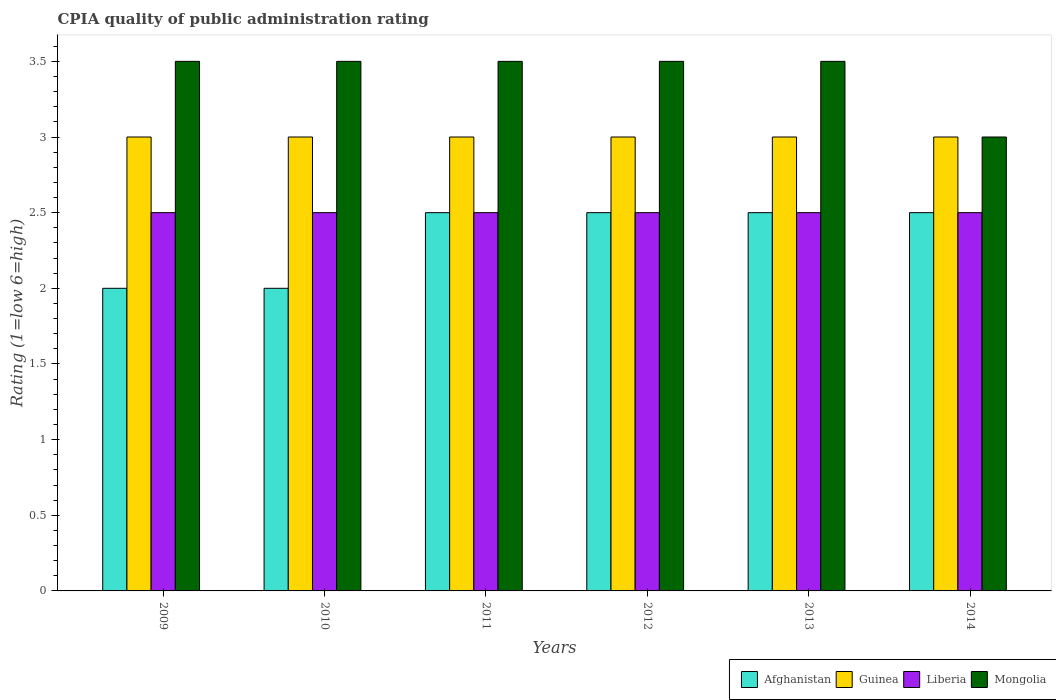How many different coloured bars are there?
Ensure brevity in your answer.  4. How many groups of bars are there?
Ensure brevity in your answer.  6. Are the number of bars on each tick of the X-axis equal?
Keep it short and to the point. Yes. How many bars are there on the 5th tick from the left?
Your answer should be compact. 4. How many bars are there on the 4th tick from the right?
Your answer should be compact. 4. What is the label of the 6th group of bars from the left?
Provide a short and direct response. 2014. What is the CPIA rating in Liberia in 2012?
Offer a terse response. 2.5. What is the total CPIA rating in Liberia in the graph?
Make the answer very short. 15. What is the difference between the CPIA rating in Afghanistan in 2009 and that in 2014?
Your response must be concise. -0.5. What is the difference between the CPIA rating in Guinea in 2011 and the CPIA rating in Liberia in 2013?
Keep it short and to the point. 0.5. What is the average CPIA rating in Mongolia per year?
Offer a terse response. 3.42. What is the ratio of the CPIA rating in Afghanistan in 2010 to that in 2012?
Offer a terse response. 0.8. What is the difference between the highest and the lowest CPIA rating in Liberia?
Make the answer very short. 0. Is it the case that in every year, the sum of the CPIA rating in Liberia and CPIA rating in Mongolia is greater than the sum of CPIA rating in Guinea and CPIA rating in Afghanistan?
Your answer should be very brief. No. What does the 3rd bar from the left in 2012 represents?
Your response must be concise. Liberia. What does the 3rd bar from the right in 2009 represents?
Provide a succinct answer. Guinea. How many bars are there?
Your response must be concise. 24. Does the graph contain grids?
Offer a very short reply. No. How many legend labels are there?
Your response must be concise. 4. What is the title of the graph?
Offer a terse response. CPIA quality of public administration rating. Does "New Zealand" appear as one of the legend labels in the graph?
Provide a short and direct response. No. What is the label or title of the Y-axis?
Offer a very short reply. Rating (1=low 6=high). What is the Rating (1=low 6=high) in Afghanistan in 2009?
Your answer should be compact. 2. What is the Rating (1=low 6=high) in Mongolia in 2009?
Offer a very short reply. 3.5. What is the Rating (1=low 6=high) in Afghanistan in 2010?
Your answer should be very brief. 2. What is the Rating (1=low 6=high) of Guinea in 2010?
Ensure brevity in your answer.  3. What is the Rating (1=low 6=high) in Guinea in 2011?
Offer a very short reply. 3. What is the Rating (1=low 6=high) of Liberia in 2011?
Give a very brief answer. 2.5. What is the Rating (1=low 6=high) in Afghanistan in 2012?
Your answer should be compact. 2.5. What is the Rating (1=low 6=high) of Guinea in 2012?
Provide a succinct answer. 3. What is the Rating (1=low 6=high) in Liberia in 2012?
Offer a very short reply. 2.5. What is the Rating (1=low 6=high) in Mongolia in 2012?
Give a very brief answer. 3.5. What is the Rating (1=low 6=high) of Afghanistan in 2013?
Make the answer very short. 2.5. What is the Rating (1=low 6=high) in Guinea in 2013?
Your response must be concise. 3. What is the Rating (1=low 6=high) of Liberia in 2013?
Ensure brevity in your answer.  2.5. What is the Rating (1=low 6=high) of Liberia in 2014?
Your response must be concise. 2.5. What is the Rating (1=low 6=high) in Mongolia in 2014?
Your answer should be very brief. 3. Across all years, what is the maximum Rating (1=low 6=high) in Afghanistan?
Make the answer very short. 2.5. Across all years, what is the maximum Rating (1=low 6=high) in Liberia?
Offer a terse response. 2.5. Across all years, what is the minimum Rating (1=low 6=high) in Mongolia?
Keep it short and to the point. 3. What is the total Rating (1=low 6=high) of Mongolia in the graph?
Provide a short and direct response. 20.5. What is the difference between the Rating (1=low 6=high) in Liberia in 2009 and that in 2010?
Offer a terse response. 0. What is the difference between the Rating (1=low 6=high) of Liberia in 2009 and that in 2011?
Your answer should be compact. 0. What is the difference between the Rating (1=low 6=high) of Mongolia in 2009 and that in 2011?
Give a very brief answer. 0. What is the difference between the Rating (1=low 6=high) in Guinea in 2009 and that in 2013?
Provide a short and direct response. 0. What is the difference between the Rating (1=low 6=high) in Mongolia in 2009 and that in 2013?
Provide a short and direct response. 0. What is the difference between the Rating (1=low 6=high) in Afghanistan in 2009 and that in 2014?
Your answer should be very brief. -0.5. What is the difference between the Rating (1=low 6=high) in Mongolia in 2009 and that in 2014?
Your response must be concise. 0.5. What is the difference between the Rating (1=low 6=high) in Liberia in 2010 and that in 2011?
Make the answer very short. 0. What is the difference between the Rating (1=low 6=high) in Guinea in 2010 and that in 2012?
Provide a short and direct response. 0. What is the difference between the Rating (1=low 6=high) of Liberia in 2010 and that in 2012?
Make the answer very short. 0. What is the difference between the Rating (1=low 6=high) of Mongolia in 2010 and that in 2013?
Provide a short and direct response. 0. What is the difference between the Rating (1=low 6=high) of Liberia in 2010 and that in 2014?
Keep it short and to the point. 0. What is the difference between the Rating (1=low 6=high) of Mongolia in 2010 and that in 2014?
Give a very brief answer. 0.5. What is the difference between the Rating (1=low 6=high) in Liberia in 2011 and that in 2012?
Ensure brevity in your answer.  0. What is the difference between the Rating (1=low 6=high) of Mongolia in 2011 and that in 2012?
Give a very brief answer. 0. What is the difference between the Rating (1=low 6=high) of Afghanistan in 2011 and that in 2013?
Provide a short and direct response. 0. What is the difference between the Rating (1=low 6=high) of Mongolia in 2011 and that in 2013?
Your answer should be very brief. 0. What is the difference between the Rating (1=low 6=high) of Afghanistan in 2011 and that in 2014?
Provide a succinct answer. 0. What is the difference between the Rating (1=low 6=high) in Guinea in 2011 and that in 2014?
Provide a succinct answer. 0. What is the difference between the Rating (1=low 6=high) in Mongolia in 2011 and that in 2014?
Your answer should be compact. 0.5. What is the difference between the Rating (1=low 6=high) of Afghanistan in 2012 and that in 2013?
Your answer should be very brief. 0. What is the difference between the Rating (1=low 6=high) in Guinea in 2012 and that in 2013?
Provide a short and direct response. 0. What is the difference between the Rating (1=low 6=high) in Liberia in 2012 and that in 2013?
Provide a short and direct response. 0. What is the difference between the Rating (1=low 6=high) in Mongolia in 2012 and that in 2013?
Make the answer very short. 0. What is the difference between the Rating (1=low 6=high) in Afghanistan in 2012 and that in 2014?
Your answer should be very brief. 0. What is the difference between the Rating (1=low 6=high) in Guinea in 2012 and that in 2014?
Ensure brevity in your answer.  0. What is the difference between the Rating (1=low 6=high) of Liberia in 2012 and that in 2014?
Ensure brevity in your answer.  0. What is the difference between the Rating (1=low 6=high) of Mongolia in 2012 and that in 2014?
Your answer should be compact. 0.5. What is the difference between the Rating (1=low 6=high) of Afghanistan in 2013 and that in 2014?
Provide a succinct answer. 0. What is the difference between the Rating (1=low 6=high) in Guinea in 2013 and that in 2014?
Your answer should be compact. 0. What is the difference between the Rating (1=low 6=high) of Mongolia in 2013 and that in 2014?
Keep it short and to the point. 0.5. What is the difference between the Rating (1=low 6=high) of Afghanistan in 2009 and the Rating (1=low 6=high) of Guinea in 2010?
Your answer should be compact. -1. What is the difference between the Rating (1=low 6=high) of Afghanistan in 2009 and the Rating (1=low 6=high) of Liberia in 2010?
Make the answer very short. -0.5. What is the difference between the Rating (1=low 6=high) in Afghanistan in 2009 and the Rating (1=low 6=high) in Mongolia in 2010?
Provide a short and direct response. -1.5. What is the difference between the Rating (1=low 6=high) in Liberia in 2009 and the Rating (1=low 6=high) in Mongolia in 2010?
Offer a terse response. -1. What is the difference between the Rating (1=low 6=high) of Afghanistan in 2009 and the Rating (1=low 6=high) of Guinea in 2011?
Keep it short and to the point. -1. What is the difference between the Rating (1=low 6=high) in Afghanistan in 2009 and the Rating (1=low 6=high) in Liberia in 2011?
Your response must be concise. -0.5. What is the difference between the Rating (1=low 6=high) of Guinea in 2009 and the Rating (1=low 6=high) of Liberia in 2011?
Your answer should be compact. 0.5. What is the difference between the Rating (1=low 6=high) in Guinea in 2009 and the Rating (1=low 6=high) in Mongolia in 2011?
Offer a very short reply. -0.5. What is the difference between the Rating (1=low 6=high) of Afghanistan in 2009 and the Rating (1=low 6=high) of Liberia in 2012?
Provide a succinct answer. -0.5. What is the difference between the Rating (1=low 6=high) in Afghanistan in 2009 and the Rating (1=low 6=high) in Mongolia in 2012?
Keep it short and to the point. -1.5. What is the difference between the Rating (1=low 6=high) of Guinea in 2009 and the Rating (1=low 6=high) of Liberia in 2012?
Make the answer very short. 0.5. What is the difference between the Rating (1=low 6=high) of Guinea in 2009 and the Rating (1=low 6=high) of Mongolia in 2012?
Offer a terse response. -0.5. What is the difference between the Rating (1=low 6=high) in Liberia in 2009 and the Rating (1=low 6=high) in Mongolia in 2012?
Your answer should be compact. -1. What is the difference between the Rating (1=low 6=high) in Afghanistan in 2009 and the Rating (1=low 6=high) in Guinea in 2013?
Provide a succinct answer. -1. What is the difference between the Rating (1=low 6=high) of Afghanistan in 2009 and the Rating (1=low 6=high) of Mongolia in 2013?
Give a very brief answer. -1.5. What is the difference between the Rating (1=low 6=high) of Guinea in 2009 and the Rating (1=low 6=high) of Liberia in 2013?
Offer a very short reply. 0.5. What is the difference between the Rating (1=low 6=high) of Guinea in 2009 and the Rating (1=low 6=high) of Mongolia in 2013?
Your response must be concise. -0.5. What is the difference between the Rating (1=low 6=high) of Afghanistan in 2009 and the Rating (1=low 6=high) of Guinea in 2014?
Keep it short and to the point. -1. What is the difference between the Rating (1=low 6=high) in Afghanistan in 2009 and the Rating (1=low 6=high) in Mongolia in 2014?
Give a very brief answer. -1. What is the difference between the Rating (1=low 6=high) of Guinea in 2010 and the Rating (1=low 6=high) of Mongolia in 2011?
Offer a terse response. -0.5. What is the difference between the Rating (1=low 6=high) of Afghanistan in 2010 and the Rating (1=low 6=high) of Liberia in 2012?
Offer a terse response. -0.5. What is the difference between the Rating (1=low 6=high) in Guinea in 2010 and the Rating (1=low 6=high) in Liberia in 2012?
Provide a short and direct response. 0.5. What is the difference between the Rating (1=low 6=high) of Liberia in 2010 and the Rating (1=low 6=high) of Mongolia in 2012?
Make the answer very short. -1. What is the difference between the Rating (1=low 6=high) of Afghanistan in 2010 and the Rating (1=low 6=high) of Guinea in 2013?
Ensure brevity in your answer.  -1. What is the difference between the Rating (1=low 6=high) in Afghanistan in 2010 and the Rating (1=low 6=high) in Liberia in 2013?
Offer a terse response. -0.5. What is the difference between the Rating (1=low 6=high) of Guinea in 2010 and the Rating (1=low 6=high) of Liberia in 2013?
Keep it short and to the point. 0.5. What is the difference between the Rating (1=low 6=high) of Guinea in 2010 and the Rating (1=low 6=high) of Mongolia in 2013?
Offer a terse response. -0.5. What is the difference between the Rating (1=low 6=high) of Liberia in 2010 and the Rating (1=low 6=high) of Mongolia in 2013?
Offer a very short reply. -1. What is the difference between the Rating (1=low 6=high) of Afghanistan in 2010 and the Rating (1=low 6=high) of Liberia in 2014?
Offer a terse response. -0.5. What is the difference between the Rating (1=low 6=high) of Guinea in 2010 and the Rating (1=low 6=high) of Liberia in 2014?
Offer a very short reply. 0.5. What is the difference between the Rating (1=low 6=high) in Guinea in 2010 and the Rating (1=low 6=high) in Mongolia in 2014?
Provide a succinct answer. 0. What is the difference between the Rating (1=low 6=high) of Afghanistan in 2011 and the Rating (1=low 6=high) of Mongolia in 2012?
Your answer should be compact. -1. What is the difference between the Rating (1=low 6=high) of Guinea in 2011 and the Rating (1=low 6=high) of Mongolia in 2012?
Give a very brief answer. -0.5. What is the difference between the Rating (1=low 6=high) of Liberia in 2011 and the Rating (1=low 6=high) of Mongolia in 2012?
Provide a succinct answer. -1. What is the difference between the Rating (1=low 6=high) in Afghanistan in 2011 and the Rating (1=low 6=high) in Guinea in 2013?
Give a very brief answer. -0.5. What is the difference between the Rating (1=low 6=high) in Guinea in 2011 and the Rating (1=low 6=high) in Mongolia in 2013?
Make the answer very short. -0.5. What is the difference between the Rating (1=low 6=high) in Liberia in 2011 and the Rating (1=low 6=high) in Mongolia in 2014?
Your answer should be very brief. -0.5. What is the difference between the Rating (1=low 6=high) in Afghanistan in 2012 and the Rating (1=low 6=high) in Liberia in 2013?
Provide a short and direct response. 0. What is the difference between the Rating (1=low 6=high) of Afghanistan in 2012 and the Rating (1=low 6=high) of Mongolia in 2013?
Make the answer very short. -1. What is the difference between the Rating (1=low 6=high) of Guinea in 2012 and the Rating (1=low 6=high) of Liberia in 2013?
Offer a very short reply. 0.5. What is the difference between the Rating (1=low 6=high) in Guinea in 2012 and the Rating (1=low 6=high) in Mongolia in 2013?
Offer a very short reply. -0.5. What is the difference between the Rating (1=low 6=high) of Liberia in 2012 and the Rating (1=low 6=high) of Mongolia in 2013?
Provide a short and direct response. -1. What is the difference between the Rating (1=low 6=high) in Afghanistan in 2012 and the Rating (1=low 6=high) in Guinea in 2014?
Offer a terse response. -0.5. What is the difference between the Rating (1=low 6=high) in Liberia in 2012 and the Rating (1=low 6=high) in Mongolia in 2014?
Your answer should be compact. -0.5. What is the difference between the Rating (1=low 6=high) in Afghanistan in 2013 and the Rating (1=low 6=high) in Guinea in 2014?
Your answer should be compact. -0.5. What is the difference between the Rating (1=low 6=high) in Afghanistan in 2013 and the Rating (1=low 6=high) in Mongolia in 2014?
Offer a very short reply. -0.5. What is the difference between the Rating (1=low 6=high) of Guinea in 2013 and the Rating (1=low 6=high) of Liberia in 2014?
Your answer should be very brief. 0.5. What is the difference between the Rating (1=low 6=high) in Guinea in 2013 and the Rating (1=low 6=high) in Mongolia in 2014?
Provide a succinct answer. 0. What is the average Rating (1=low 6=high) in Afghanistan per year?
Make the answer very short. 2.33. What is the average Rating (1=low 6=high) of Mongolia per year?
Make the answer very short. 3.42. In the year 2010, what is the difference between the Rating (1=low 6=high) of Afghanistan and Rating (1=low 6=high) of Guinea?
Keep it short and to the point. -1. In the year 2010, what is the difference between the Rating (1=low 6=high) in Afghanistan and Rating (1=low 6=high) in Mongolia?
Your answer should be compact. -1.5. In the year 2011, what is the difference between the Rating (1=low 6=high) in Afghanistan and Rating (1=low 6=high) in Liberia?
Offer a very short reply. 0. In the year 2011, what is the difference between the Rating (1=low 6=high) of Afghanistan and Rating (1=low 6=high) of Mongolia?
Give a very brief answer. -1. In the year 2011, what is the difference between the Rating (1=low 6=high) of Guinea and Rating (1=low 6=high) of Liberia?
Keep it short and to the point. 0.5. In the year 2011, what is the difference between the Rating (1=low 6=high) in Guinea and Rating (1=low 6=high) in Mongolia?
Ensure brevity in your answer.  -0.5. In the year 2011, what is the difference between the Rating (1=low 6=high) in Liberia and Rating (1=low 6=high) in Mongolia?
Keep it short and to the point. -1. In the year 2012, what is the difference between the Rating (1=low 6=high) in Afghanistan and Rating (1=low 6=high) in Liberia?
Ensure brevity in your answer.  0. In the year 2012, what is the difference between the Rating (1=low 6=high) in Afghanistan and Rating (1=low 6=high) in Mongolia?
Your response must be concise. -1. In the year 2012, what is the difference between the Rating (1=low 6=high) of Guinea and Rating (1=low 6=high) of Mongolia?
Keep it short and to the point. -0.5. In the year 2013, what is the difference between the Rating (1=low 6=high) in Afghanistan and Rating (1=low 6=high) in Mongolia?
Your answer should be compact. -1. In the year 2014, what is the difference between the Rating (1=low 6=high) of Afghanistan and Rating (1=low 6=high) of Mongolia?
Give a very brief answer. -0.5. In the year 2014, what is the difference between the Rating (1=low 6=high) of Guinea and Rating (1=low 6=high) of Mongolia?
Your answer should be compact. 0. In the year 2014, what is the difference between the Rating (1=low 6=high) of Liberia and Rating (1=low 6=high) of Mongolia?
Offer a very short reply. -0.5. What is the ratio of the Rating (1=low 6=high) of Guinea in 2009 to that in 2010?
Your answer should be very brief. 1. What is the ratio of the Rating (1=low 6=high) of Liberia in 2009 to that in 2010?
Provide a short and direct response. 1. What is the ratio of the Rating (1=low 6=high) of Mongolia in 2009 to that in 2010?
Give a very brief answer. 1. What is the ratio of the Rating (1=low 6=high) in Afghanistan in 2009 to that in 2011?
Your answer should be compact. 0.8. What is the ratio of the Rating (1=low 6=high) in Guinea in 2009 to that in 2012?
Your answer should be very brief. 1. What is the ratio of the Rating (1=low 6=high) of Mongolia in 2009 to that in 2012?
Offer a terse response. 1. What is the ratio of the Rating (1=low 6=high) in Afghanistan in 2009 to that in 2014?
Make the answer very short. 0.8. What is the ratio of the Rating (1=low 6=high) of Guinea in 2009 to that in 2014?
Your response must be concise. 1. What is the ratio of the Rating (1=low 6=high) of Mongolia in 2009 to that in 2014?
Ensure brevity in your answer.  1.17. What is the ratio of the Rating (1=low 6=high) of Guinea in 2010 to that in 2011?
Your answer should be very brief. 1. What is the ratio of the Rating (1=low 6=high) in Mongolia in 2010 to that in 2011?
Provide a short and direct response. 1. What is the ratio of the Rating (1=low 6=high) of Guinea in 2010 to that in 2013?
Your answer should be very brief. 1. What is the ratio of the Rating (1=low 6=high) of Liberia in 2010 to that in 2014?
Provide a succinct answer. 1. What is the ratio of the Rating (1=low 6=high) in Afghanistan in 2011 to that in 2012?
Provide a succinct answer. 1. What is the ratio of the Rating (1=low 6=high) of Guinea in 2011 to that in 2012?
Offer a terse response. 1. What is the ratio of the Rating (1=low 6=high) in Mongolia in 2011 to that in 2013?
Keep it short and to the point. 1. What is the ratio of the Rating (1=low 6=high) of Liberia in 2011 to that in 2014?
Your answer should be compact. 1. What is the ratio of the Rating (1=low 6=high) in Afghanistan in 2012 to that in 2013?
Provide a short and direct response. 1. What is the ratio of the Rating (1=low 6=high) in Afghanistan in 2012 to that in 2014?
Keep it short and to the point. 1. What is the ratio of the Rating (1=low 6=high) in Guinea in 2012 to that in 2014?
Provide a short and direct response. 1. What is the ratio of the Rating (1=low 6=high) of Afghanistan in 2013 to that in 2014?
Give a very brief answer. 1. What is the ratio of the Rating (1=low 6=high) in Guinea in 2013 to that in 2014?
Offer a very short reply. 1. What is the ratio of the Rating (1=low 6=high) of Liberia in 2013 to that in 2014?
Give a very brief answer. 1. What is the difference between the highest and the second highest Rating (1=low 6=high) of Guinea?
Provide a short and direct response. 0. What is the difference between the highest and the second highest Rating (1=low 6=high) in Liberia?
Offer a very short reply. 0. What is the difference between the highest and the lowest Rating (1=low 6=high) of Guinea?
Your answer should be very brief. 0. What is the difference between the highest and the lowest Rating (1=low 6=high) in Liberia?
Give a very brief answer. 0. What is the difference between the highest and the lowest Rating (1=low 6=high) in Mongolia?
Offer a very short reply. 0.5. 